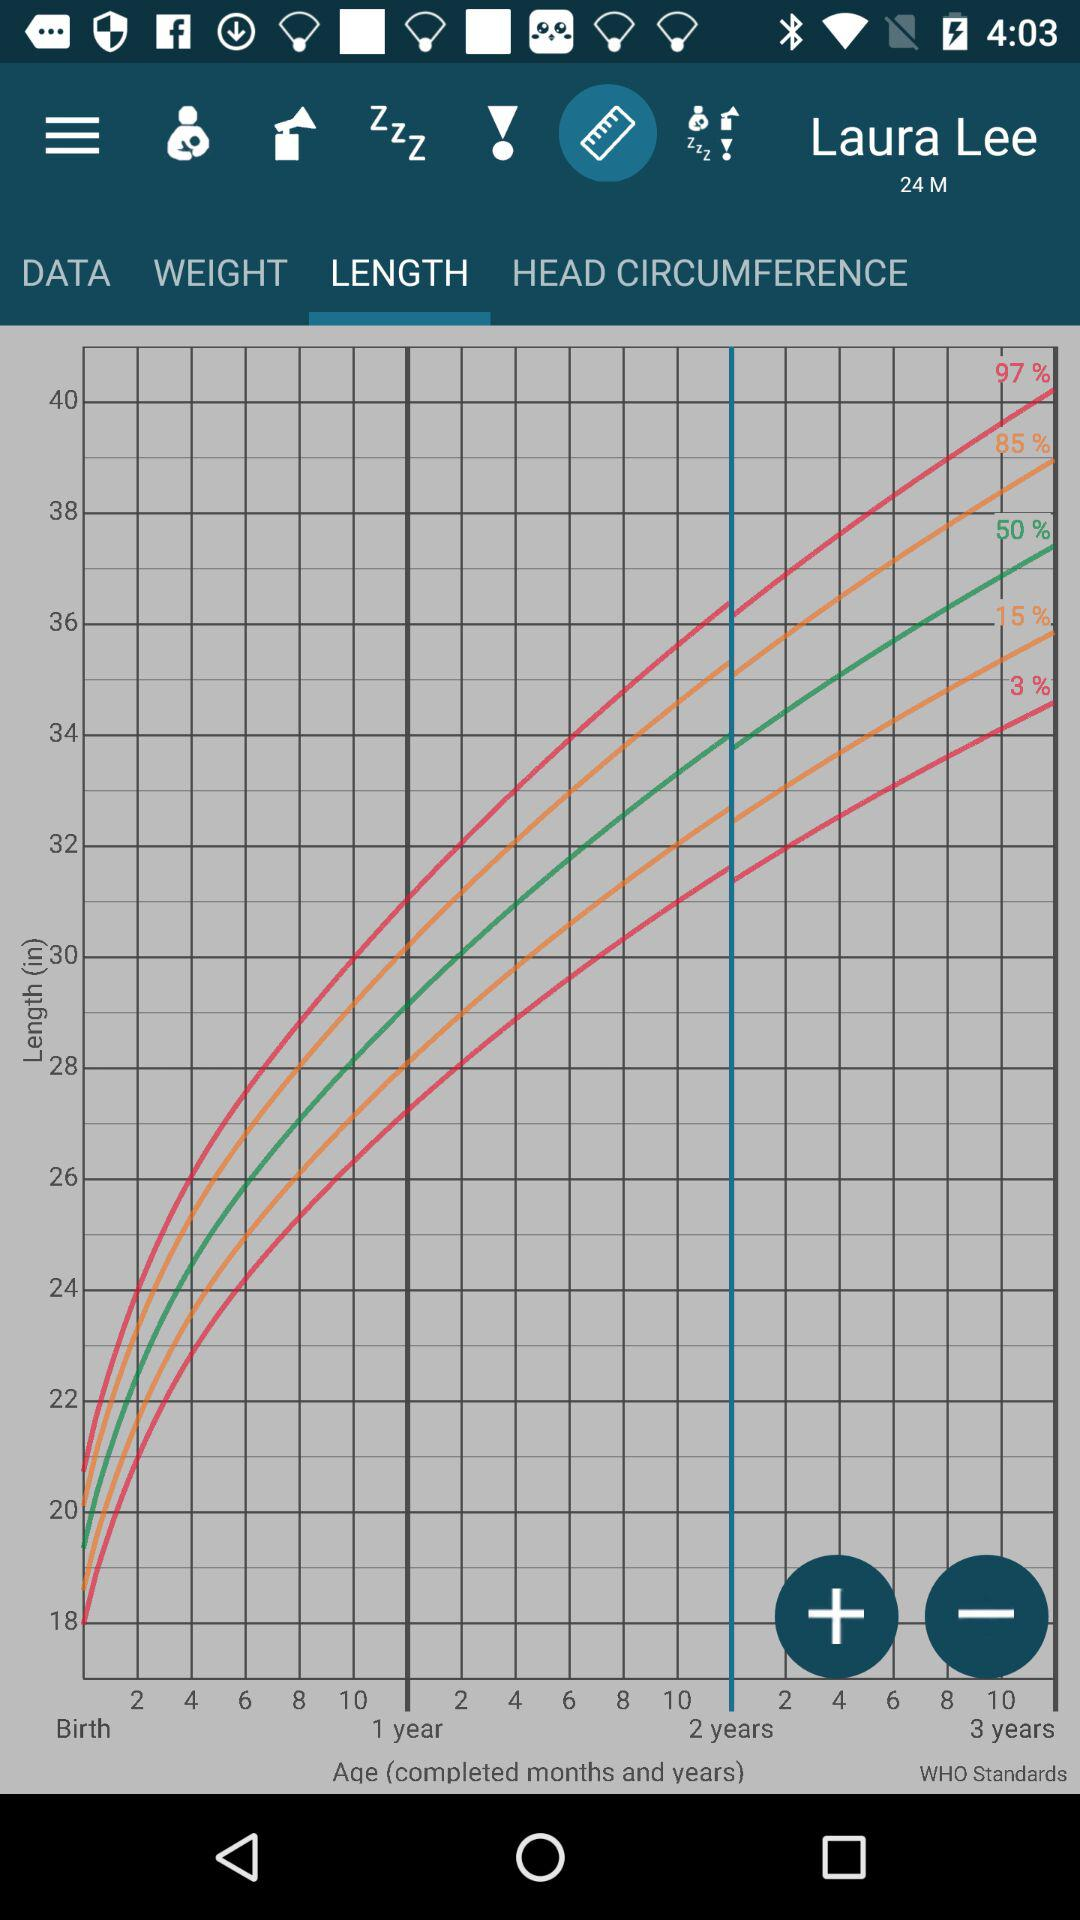What is the age of the baby? The age of the baby is 24 months. 